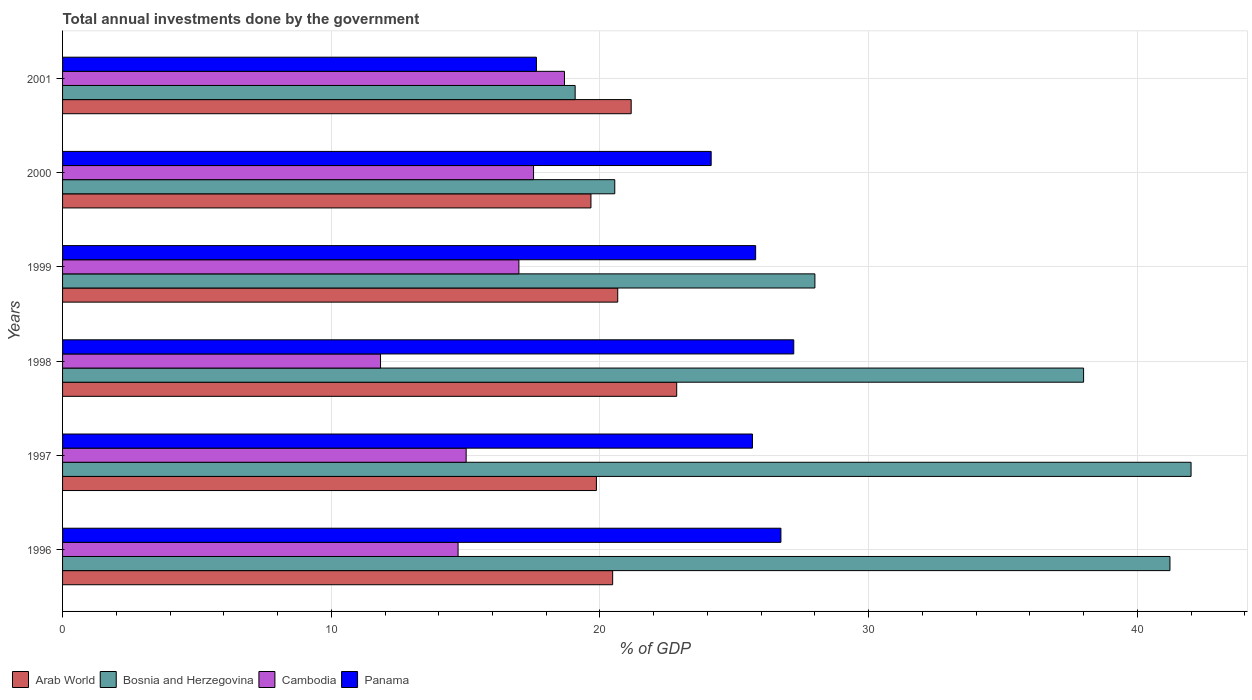How many bars are there on the 6th tick from the top?
Make the answer very short. 4. How many bars are there on the 1st tick from the bottom?
Make the answer very short. 4. What is the label of the 5th group of bars from the top?
Make the answer very short. 1997. What is the total annual investments done by the government in Cambodia in 2000?
Ensure brevity in your answer.  17.53. Across all years, what is the maximum total annual investments done by the government in Arab World?
Your response must be concise. 22.86. Across all years, what is the minimum total annual investments done by the government in Arab World?
Ensure brevity in your answer.  19.67. What is the total total annual investments done by the government in Bosnia and Herzegovina in the graph?
Provide a succinct answer. 188.84. What is the difference between the total annual investments done by the government in Panama in 1999 and that in 2000?
Your answer should be very brief. 1.66. What is the difference between the total annual investments done by the government in Panama in 2000 and the total annual investments done by the government in Cambodia in 2001?
Provide a short and direct response. 5.46. What is the average total annual investments done by the government in Arab World per year?
Make the answer very short. 20.78. In the year 1999, what is the difference between the total annual investments done by the government in Arab World and total annual investments done by the government in Cambodia?
Provide a short and direct response. 3.68. In how many years, is the total annual investments done by the government in Arab World greater than 2 %?
Offer a very short reply. 6. What is the ratio of the total annual investments done by the government in Panama in 1996 to that in 1997?
Provide a succinct answer. 1.04. Is the difference between the total annual investments done by the government in Arab World in 1996 and 1999 greater than the difference between the total annual investments done by the government in Cambodia in 1996 and 1999?
Your answer should be very brief. Yes. What is the difference between the highest and the second highest total annual investments done by the government in Bosnia and Herzegovina?
Give a very brief answer. 0.79. What is the difference between the highest and the lowest total annual investments done by the government in Arab World?
Provide a short and direct response. 3.19. In how many years, is the total annual investments done by the government in Bosnia and Herzegovina greater than the average total annual investments done by the government in Bosnia and Herzegovina taken over all years?
Provide a short and direct response. 3. Is it the case that in every year, the sum of the total annual investments done by the government in Bosnia and Herzegovina and total annual investments done by the government in Panama is greater than the sum of total annual investments done by the government in Arab World and total annual investments done by the government in Cambodia?
Your answer should be very brief. Yes. What does the 4th bar from the top in 1996 represents?
Your response must be concise. Arab World. What does the 4th bar from the bottom in 1999 represents?
Provide a succinct answer. Panama. How many bars are there?
Ensure brevity in your answer.  24. How many years are there in the graph?
Make the answer very short. 6. What is the difference between two consecutive major ticks on the X-axis?
Your answer should be compact. 10. Does the graph contain any zero values?
Offer a terse response. No. How many legend labels are there?
Make the answer very short. 4. What is the title of the graph?
Ensure brevity in your answer.  Total annual investments done by the government. Does "Turks and Caicos Islands" appear as one of the legend labels in the graph?
Offer a terse response. No. What is the label or title of the X-axis?
Offer a very short reply. % of GDP. What is the label or title of the Y-axis?
Your answer should be compact. Years. What is the % of GDP of Arab World in 1996?
Give a very brief answer. 20.47. What is the % of GDP of Bosnia and Herzegovina in 1996?
Make the answer very short. 41.21. What is the % of GDP in Cambodia in 1996?
Your answer should be compact. 14.72. What is the % of GDP in Panama in 1996?
Ensure brevity in your answer.  26.74. What is the % of GDP in Arab World in 1997?
Offer a very short reply. 19.87. What is the % of GDP in Bosnia and Herzegovina in 1997?
Give a very brief answer. 42. What is the % of GDP in Cambodia in 1997?
Keep it short and to the point. 15.02. What is the % of GDP in Panama in 1997?
Your answer should be very brief. 25.68. What is the % of GDP of Arab World in 1998?
Provide a succinct answer. 22.86. What is the % of GDP of Bosnia and Herzegovina in 1998?
Your response must be concise. 38. What is the % of GDP in Cambodia in 1998?
Make the answer very short. 11.83. What is the % of GDP in Panama in 1998?
Give a very brief answer. 27.21. What is the % of GDP of Arab World in 1999?
Keep it short and to the point. 20.66. What is the % of GDP of Bosnia and Herzegovina in 1999?
Ensure brevity in your answer.  28. What is the % of GDP of Cambodia in 1999?
Offer a terse response. 16.98. What is the % of GDP of Panama in 1999?
Provide a succinct answer. 25.79. What is the % of GDP of Arab World in 2000?
Ensure brevity in your answer.  19.67. What is the % of GDP in Bosnia and Herzegovina in 2000?
Give a very brief answer. 20.55. What is the % of GDP in Cambodia in 2000?
Keep it short and to the point. 17.53. What is the % of GDP in Panama in 2000?
Give a very brief answer. 24.14. What is the % of GDP of Arab World in 2001?
Provide a succinct answer. 21.16. What is the % of GDP in Bosnia and Herzegovina in 2001?
Offer a very short reply. 19.08. What is the % of GDP in Cambodia in 2001?
Give a very brief answer. 18.68. What is the % of GDP of Panama in 2001?
Keep it short and to the point. 17.64. Across all years, what is the maximum % of GDP in Arab World?
Give a very brief answer. 22.86. Across all years, what is the maximum % of GDP in Bosnia and Herzegovina?
Provide a succinct answer. 42. Across all years, what is the maximum % of GDP of Cambodia?
Your response must be concise. 18.68. Across all years, what is the maximum % of GDP in Panama?
Provide a succinct answer. 27.21. Across all years, what is the minimum % of GDP of Arab World?
Offer a terse response. 19.67. Across all years, what is the minimum % of GDP in Bosnia and Herzegovina?
Provide a short and direct response. 19.08. Across all years, what is the minimum % of GDP of Cambodia?
Ensure brevity in your answer.  11.83. Across all years, what is the minimum % of GDP in Panama?
Make the answer very short. 17.64. What is the total % of GDP in Arab World in the graph?
Provide a short and direct response. 124.69. What is the total % of GDP of Bosnia and Herzegovina in the graph?
Provide a short and direct response. 188.84. What is the total % of GDP in Cambodia in the graph?
Give a very brief answer. 94.77. What is the total % of GDP in Panama in the graph?
Your answer should be very brief. 147.2. What is the difference between the % of GDP of Arab World in 1996 and that in 1997?
Make the answer very short. 0.6. What is the difference between the % of GDP of Bosnia and Herzegovina in 1996 and that in 1997?
Provide a succinct answer. -0.79. What is the difference between the % of GDP of Cambodia in 1996 and that in 1997?
Your response must be concise. -0.3. What is the difference between the % of GDP in Panama in 1996 and that in 1997?
Offer a terse response. 1.06. What is the difference between the % of GDP in Arab World in 1996 and that in 1998?
Your response must be concise. -2.38. What is the difference between the % of GDP of Bosnia and Herzegovina in 1996 and that in 1998?
Provide a succinct answer. 3.21. What is the difference between the % of GDP in Cambodia in 1996 and that in 1998?
Offer a terse response. 2.89. What is the difference between the % of GDP of Panama in 1996 and that in 1998?
Offer a very short reply. -0.48. What is the difference between the % of GDP of Arab World in 1996 and that in 1999?
Your answer should be compact. -0.19. What is the difference between the % of GDP of Bosnia and Herzegovina in 1996 and that in 1999?
Your response must be concise. 13.21. What is the difference between the % of GDP in Cambodia in 1996 and that in 1999?
Offer a very short reply. -2.26. What is the difference between the % of GDP of Panama in 1996 and that in 1999?
Make the answer very short. 0.94. What is the difference between the % of GDP in Arab World in 1996 and that in 2000?
Provide a short and direct response. 0.81. What is the difference between the % of GDP of Bosnia and Herzegovina in 1996 and that in 2000?
Keep it short and to the point. 20.66. What is the difference between the % of GDP of Cambodia in 1996 and that in 2000?
Provide a succinct answer. -2.81. What is the difference between the % of GDP of Panama in 1996 and that in 2000?
Ensure brevity in your answer.  2.6. What is the difference between the % of GDP of Arab World in 1996 and that in 2001?
Keep it short and to the point. -0.69. What is the difference between the % of GDP in Bosnia and Herzegovina in 1996 and that in 2001?
Keep it short and to the point. 22.14. What is the difference between the % of GDP in Cambodia in 1996 and that in 2001?
Make the answer very short. -3.96. What is the difference between the % of GDP of Panama in 1996 and that in 2001?
Your answer should be compact. 9.1. What is the difference between the % of GDP in Arab World in 1997 and that in 1998?
Provide a succinct answer. -2.99. What is the difference between the % of GDP of Bosnia and Herzegovina in 1997 and that in 1998?
Ensure brevity in your answer.  4. What is the difference between the % of GDP of Cambodia in 1997 and that in 1998?
Make the answer very short. 3.19. What is the difference between the % of GDP in Panama in 1997 and that in 1998?
Your response must be concise. -1.54. What is the difference between the % of GDP of Arab World in 1997 and that in 1999?
Your response must be concise. -0.79. What is the difference between the % of GDP of Bosnia and Herzegovina in 1997 and that in 1999?
Offer a terse response. 14. What is the difference between the % of GDP in Cambodia in 1997 and that in 1999?
Ensure brevity in your answer.  -1.96. What is the difference between the % of GDP in Panama in 1997 and that in 1999?
Give a very brief answer. -0.12. What is the difference between the % of GDP of Arab World in 1997 and that in 2000?
Ensure brevity in your answer.  0.2. What is the difference between the % of GDP in Bosnia and Herzegovina in 1997 and that in 2000?
Your answer should be compact. 21.45. What is the difference between the % of GDP of Cambodia in 1997 and that in 2000?
Make the answer very short. -2.51. What is the difference between the % of GDP of Panama in 1997 and that in 2000?
Provide a short and direct response. 1.54. What is the difference between the % of GDP of Arab World in 1997 and that in 2001?
Your response must be concise. -1.29. What is the difference between the % of GDP of Bosnia and Herzegovina in 1997 and that in 2001?
Offer a very short reply. 22.92. What is the difference between the % of GDP in Cambodia in 1997 and that in 2001?
Your answer should be compact. -3.66. What is the difference between the % of GDP of Panama in 1997 and that in 2001?
Give a very brief answer. 8.04. What is the difference between the % of GDP in Arab World in 1998 and that in 1999?
Keep it short and to the point. 2.19. What is the difference between the % of GDP in Bosnia and Herzegovina in 1998 and that in 1999?
Ensure brevity in your answer.  10. What is the difference between the % of GDP in Cambodia in 1998 and that in 1999?
Offer a terse response. -5.15. What is the difference between the % of GDP of Panama in 1998 and that in 1999?
Make the answer very short. 1.42. What is the difference between the % of GDP of Arab World in 1998 and that in 2000?
Provide a short and direct response. 3.19. What is the difference between the % of GDP in Bosnia and Herzegovina in 1998 and that in 2000?
Ensure brevity in your answer.  17.45. What is the difference between the % of GDP of Cambodia in 1998 and that in 2000?
Keep it short and to the point. -5.7. What is the difference between the % of GDP of Panama in 1998 and that in 2000?
Offer a very short reply. 3.07. What is the difference between the % of GDP of Arab World in 1998 and that in 2001?
Make the answer very short. 1.69. What is the difference between the % of GDP of Bosnia and Herzegovina in 1998 and that in 2001?
Offer a terse response. 18.92. What is the difference between the % of GDP in Cambodia in 1998 and that in 2001?
Provide a short and direct response. -6.85. What is the difference between the % of GDP of Panama in 1998 and that in 2001?
Your answer should be compact. 9.58. What is the difference between the % of GDP in Bosnia and Herzegovina in 1999 and that in 2000?
Provide a short and direct response. 7.45. What is the difference between the % of GDP in Cambodia in 1999 and that in 2000?
Offer a very short reply. -0.55. What is the difference between the % of GDP in Panama in 1999 and that in 2000?
Make the answer very short. 1.66. What is the difference between the % of GDP in Arab World in 1999 and that in 2001?
Make the answer very short. -0.5. What is the difference between the % of GDP of Bosnia and Herzegovina in 1999 and that in 2001?
Make the answer very short. 8.92. What is the difference between the % of GDP in Cambodia in 1999 and that in 2001?
Offer a very short reply. -1.7. What is the difference between the % of GDP in Panama in 1999 and that in 2001?
Provide a succinct answer. 8.16. What is the difference between the % of GDP of Arab World in 2000 and that in 2001?
Provide a short and direct response. -1.5. What is the difference between the % of GDP of Bosnia and Herzegovina in 2000 and that in 2001?
Your response must be concise. 1.47. What is the difference between the % of GDP of Cambodia in 2000 and that in 2001?
Offer a very short reply. -1.15. What is the difference between the % of GDP of Panama in 2000 and that in 2001?
Offer a terse response. 6.5. What is the difference between the % of GDP of Arab World in 1996 and the % of GDP of Bosnia and Herzegovina in 1997?
Ensure brevity in your answer.  -21.53. What is the difference between the % of GDP in Arab World in 1996 and the % of GDP in Cambodia in 1997?
Provide a succinct answer. 5.45. What is the difference between the % of GDP in Arab World in 1996 and the % of GDP in Panama in 1997?
Offer a terse response. -5.2. What is the difference between the % of GDP of Bosnia and Herzegovina in 1996 and the % of GDP of Cambodia in 1997?
Your answer should be very brief. 26.19. What is the difference between the % of GDP of Bosnia and Herzegovina in 1996 and the % of GDP of Panama in 1997?
Give a very brief answer. 15.54. What is the difference between the % of GDP in Cambodia in 1996 and the % of GDP in Panama in 1997?
Keep it short and to the point. -10.96. What is the difference between the % of GDP in Arab World in 1996 and the % of GDP in Bosnia and Herzegovina in 1998?
Make the answer very short. -17.53. What is the difference between the % of GDP in Arab World in 1996 and the % of GDP in Cambodia in 1998?
Your answer should be very brief. 8.64. What is the difference between the % of GDP of Arab World in 1996 and the % of GDP of Panama in 1998?
Give a very brief answer. -6.74. What is the difference between the % of GDP in Bosnia and Herzegovina in 1996 and the % of GDP in Cambodia in 1998?
Ensure brevity in your answer.  29.38. What is the difference between the % of GDP of Bosnia and Herzegovina in 1996 and the % of GDP of Panama in 1998?
Your answer should be compact. 14. What is the difference between the % of GDP of Cambodia in 1996 and the % of GDP of Panama in 1998?
Offer a very short reply. -12.49. What is the difference between the % of GDP of Arab World in 1996 and the % of GDP of Bosnia and Herzegovina in 1999?
Keep it short and to the point. -7.53. What is the difference between the % of GDP of Arab World in 1996 and the % of GDP of Cambodia in 1999?
Your answer should be very brief. 3.49. What is the difference between the % of GDP in Arab World in 1996 and the % of GDP in Panama in 1999?
Keep it short and to the point. -5.32. What is the difference between the % of GDP of Bosnia and Herzegovina in 1996 and the % of GDP of Cambodia in 1999?
Give a very brief answer. 24.23. What is the difference between the % of GDP of Bosnia and Herzegovina in 1996 and the % of GDP of Panama in 1999?
Keep it short and to the point. 15.42. What is the difference between the % of GDP of Cambodia in 1996 and the % of GDP of Panama in 1999?
Offer a terse response. -11.07. What is the difference between the % of GDP of Arab World in 1996 and the % of GDP of Bosnia and Herzegovina in 2000?
Provide a succinct answer. -0.08. What is the difference between the % of GDP in Arab World in 1996 and the % of GDP in Cambodia in 2000?
Provide a short and direct response. 2.94. What is the difference between the % of GDP of Arab World in 1996 and the % of GDP of Panama in 2000?
Your answer should be very brief. -3.67. What is the difference between the % of GDP of Bosnia and Herzegovina in 1996 and the % of GDP of Cambodia in 2000?
Offer a very short reply. 23.68. What is the difference between the % of GDP in Bosnia and Herzegovina in 1996 and the % of GDP in Panama in 2000?
Offer a very short reply. 17.07. What is the difference between the % of GDP in Cambodia in 1996 and the % of GDP in Panama in 2000?
Ensure brevity in your answer.  -9.42. What is the difference between the % of GDP of Arab World in 1996 and the % of GDP of Bosnia and Herzegovina in 2001?
Give a very brief answer. 1.4. What is the difference between the % of GDP in Arab World in 1996 and the % of GDP in Cambodia in 2001?
Your answer should be very brief. 1.79. What is the difference between the % of GDP of Arab World in 1996 and the % of GDP of Panama in 2001?
Give a very brief answer. 2.84. What is the difference between the % of GDP of Bosnia and Herzegovina in 1996 and the % of GDP of Cambodia in 2001?
Make the answer very short. 22.53. What is the difference between the % of GDP in Bosnia and Herzegovina in 1996 and the % of GDP in Panama in 2001?
Offer a very short reply. 23.58. What is the difference between the % of GDP of Cambodia in 1996 and the % of GDP of Panama in 2001?
Keep it short and to the point. -2.92. What is the difference between the % of GDP of Arab World in 1997 and the % of GDP of Bosnia and Herzegovina in 1998?
Your response must be concise. -18.13. What is the difference between the % of GDP in Arab World in 1997 and the % of GDP in Cambodia in 1998?
Your response must be concise. 8.03. What is the difference between the % of GDP of Arab World in 1997 and the % of GDP of Panama in 1998?
Provide a short and direct response. -7.35. What is the difference between the % of GDP in Bosnia and Herzegovina in 1997 and the % of GDP in Cambodia in 1998?
Provide a succinct answer. 30.17. What is the difference between the % of GDP in Bosnia and Herzegovina in 1997 and the % of GDP in Panama in 1998?
Make the answer very short. 14.79. What is the difference between the % of GDP of Cambodia in 1997 and the % of GDP of Panama in 1998?
Your answer should be compact. -12.19. What is the difference between the % of GDP in Arab World in 1997 and the % of GDP in Bosnia and Herzegovina in 1999?
Offer a very short reply. -8.13. What is the difference between the % of GDP of Arab World in 1997 and the % of GDP of Cambodia in 1999?
Give a very brief answer. 2.88. What is the difference between the % of GDP of Arab World in 1997 and the % of GDP of Panama in 1999?
Your answer should be very brief. -5.93. What is the difference between the % of GDP in Bosnia and Herzegovina in 1997 and the % of GDP in Cambodia in 1999?
Offer a terse response. 25.02. What is the difference between the % of GDP of Bosnia and Herzegovina in 1997 and the % of GDP of Panama in 1999?
Provide a succinct answer. 16.21. What is the difference between the % of GDP of Cambodia in 1997 and the % of GDP of Panama in 1999?
Keep it short and to the point. -10.77. What is the difference between the % of GDP in Arab World in 1997 and the % of GDP in Bosnia and Herzegovina in 2000?
Keep it short and to the point. -0.68. What is the difference between the % of GDP in Arab World in 1997 and the % of GDP in Cambodia in 2000?
Provide a succinct answer. 2.34. What is the difference between the % of GDP in Arab World in 1997 and the % of GDP in Panama in 2000?
Your response must be concise. -4.27. What is the difference between the % of GDP in Bosnia and Herzegovina in 1997 and the % of GDP in Cambodia in 2000?
Your response must be concise. 24.47. What is the difference between the % of GDP of Bosnia and Herzegovina in 1997 and the % of GDP of Panama in 2000?
Your response must be concise. 17.86. What is the difference between the % of GDP of Cambodia in 1997 and the % of GDP of Panama in 2000?
Your answer should be very brief. -9.12. What is the difference between the % of GDP in Arab World in 1997 and the % of GDP in Bosnia and Herzegovina in 2001?
Your answer should be compact. 0.79. What is the difference between the % of GDP of Arab World in 1997 and the % of GDP of Cambodia in 2001?
Keep it short and to the point. 1.19. What is the difference between the % of GDP in Arab World in 1997 and the % of GDP in Panama in 2001?
Offer a very short reply. 2.23. What is the difference between the % of GDP in Bosnia and Herzegovina in 1997 and the % of GDP in Cambodia in 2001?
Keep it short and to the point. 23.32. What is the difference between the % of GDP in Bosnia and Herzegovina in 1997 and the % of GDP in Panama in 2001?
Provide a short and direct response. 24.36. What is the difference between the % of GDP of Cambodia in 1997 and the % of GDP of Panama in 2001?
Your answer should be very brief. -2.62. What is the difference between the % of GDP of Arab World in 1998 and the % of GDP of Bosnia and Herzegovina in 1999?
Offer a very short reply. -5.14. What is the difference between the % of GDP of Arab World in 1998 and the % of GDP of Cambodia in 1999?
Your response must be concise. 5.87. What is the difference between the % of GDP of Arab World in 1998 and the % of GDP of Panama in 1999?
Your answer should be very brief. -2.94. What is the difference between the % of GDP in Bosnia and Herzegovina in 1998 and the % of GDP in Cambodia in 1999?
Give a very brief answer. 21.02. What is the difference between the % of GDP in Bosnia and Herzegovina in 1998 and the % of GDP in Panama in 1999?
Give a very brief answer. 12.21. What is the difference between the % of GDP in Cambodia in 1998 and the % of GDP in Panama in 1999?
Provide a succinct answer. -13.96. What is the difference between the % of GDP in Arab World in 1998 and the % of GDP in Bosnia and Herzegovina in 2000?
Your answer should be very brief. 2.31. What is the difference between the % of GDP of Arab World in 1998 and the % of GDP of Cambodia in 2000?
Your answer should be very brief. 5.33. What is the difference between the % of GDP of Arab World in 1998 and the % of GDP of Panama in 2000?
Your response must be concise. -1.28. What is the difference between the % of GDP in Bosnia and Herzegovina in 1998 and the % of GDP in Cambodia in 2000?
Keep it short and to the point. 20.47. What is the difference between the % of GDP in Bosnia and Herzegovina in 1998 and the % of GDP in Panama in 2000?
Provide a succinct answer. 13.86. What is the difference between the % of GDP of Cambodia in 1998 and the % of GDP of Panama in 2000?
Give a very brief answer. -12.31. What is the difference between the % of GDP of Arab World in 1998 and the % of GDP of Bosnia and Herzegovina in 2001?
Your response must be concise. 3.78. What is the difference between the % of GDP of Arab World in 1998 and the % of GDP of Cambodia in 2001?
Provide a short and direct response. 4.18. What is the difference between the % of GDP in Arab World in 1998 and the % of GDP in Panama in 2001?
Ensure brevity in your answer.  5.22. What is the difference between the % of GDP in Bosnia and Herzegovina in 1998 and the % of GDP in Cambodia in 2001?
Give a very brief answer. 19.32. What is the difference between the % of GDP in Bosnia and Herzegovina in 1998 and the % of GDP in Panama in 2001?
Provide a succinct answer. 20.36. What is the difference between the % of GDP in Cambodia in 1998 and the % of GDP in Panama in 2001?
Provide a succinct answer. -5.8. What is the difference between the % of GDP of Arab World in 1999 and the % of GDP of Bosnia and Herzegovina in 2000?
Keep it short and to the point. 0.11. What is the difference between the % of GDP of Arab World in 1999 and the % of GDP of Cambodia in 2000?
Your answer should be very brief. 3.13. What is the difference between the % of GDP of Arab World in 1999 and the % of GDP of Panama in 2000?
Your response must be concise. -3.48. What is the difference between the % of GDP in Bosnia and Herzegovina in 1999 and the % of GDP in Cambodia in 2000?
Ensure brevity in your answer.  10.47. What is the difference between the % of GDP in Bosnia and Herzegovina in 1999 and the % of GDP in Panama in 2000?
Make the answer very short. 3.86. What is the difference between the % of GDP in Cambodia in 1999 and the % of GDP in Panama in 2000?
Your answer should be compact. -7.16. What is the difference between the % of GDP in Arab World in 1999 and the % of GDP in Bosnia and Herzegovina in 2001?
Your response must be concise. 1.58. What is the difference between the % of GDP in Arab World in 1999 and the % of GDP in Cambodia in 2001?
Give a very brief answer. 1.98. What is the difference between the % of GDP of Arab World in 1999 and the % of GDP of Panama in 2001?
Keep it short and to the point. 3.02. What is the difference between the % of GDP of Bosnia and Herzegovina in 1999 and the % of GDP of Cambodia in 2001?
Provide a succinct answer. 9.32. What is the difference between the % of GDP in Bosnia and Herzegovina in 1999 and the % of GDP in Panama in 2001?
Offer a very short reply. 10.36. What is the difference between the % of GDP of Cambodia in 1999 and the % of GDP of Panama in 2001?
Your answer should be very brief. -0.65. What is the difference between the % of GDP of Arab World in 2000 and the % of GDP of Bosnia and Herzegovina in 2001?
Your answer should be compact. 0.59. What is the difference between the % of GDP in Arab World in 2000 and the % of GDP in Cambodia in 2001?
Ensure brevity in your answer.  0.99. What is the difference between the % of GDP of Arab World in 2000 and the % of GDP of Panama in 2001?
Your response must be concise. 2.03. What is the difference between the % of GDP in Bosnia and Herzegovina in 2000 and the % of GDP in Cambodia in 2001?
Ensure brevity in your answer.  1.87. What is the difference between the % of GDP in Bosnia and Herzegovina in 2000 and the % of GDP in Panama in 2001?
Provide a short and direct response. 2.91. What is the difference between the % of GDP of Cambodia in 2000 and the % of GDP of Panama in 2001?
Offer a terse response. -0.11. What is the average % of GDP of Arab World per year?
Make the answer very short. 20.78. What is the average % of GDP in Bosnia and Herzegovina per year?
Offer a terse response. 31.47. What is the average % of GDP of Cambodia per year?
Give a very brief answer. 15.79. What is the average % of GDP of Panama per year?
Keep it short and to the point. 24.53. In the year 1996, what is the difference between the % of GDP of Arab World and % of GDP of Bosnia and Herzegovina?
Keep it short and to the point. -20.74. In the year 1996, what is the difference between the % of GDP in Arab World and % of GDP in Cambodia?
Your response must be concise. 5.75. In the year 1996, what is the difference between the % of GDP in Arab World and % of GDP in Panama?
Your answer should be compact. -6.26. In the year 1996, what is the difference between the % of GDP in Bosnia and Herzegovina and % of GDP in Cambodia?
Your response must be concise. 26.49. In the year 1996, what is the difference between the % of GDP of Bosnia and Herzegovina and % of GDP of Panama?
Offer a very short reply. 14.48. In the year 1996, what is the difference between the % of GDP of Cambodia and % of GDP of Panama?
Keep it short and to the point. -12.02. In the year 1997, what is the difference between the % of GDP of Arab World and % of GDP of Bosnia and Herzegovina?
Offer a very short reply. -22.13. In the year 1997, what is the difference between the % of GDP in Arab World and % of GDP in Cambodia?
Provide a succinct answer. 4.85. In the year 1997, what is the difference between the % of GDP in Arab World and % of GDP in Panama?
Offer a terse response. -5.81. In the year 1997, what is the difference between the % of GDP in Bosnia and Herzegovina and % of GDP in Cambodia?
Provide a succinct answer. 26.98. In the year 1997, what is the difference between the % of GDP of Bosnia and Herzegovina and % of GDP of Panama?
Your answer should be very brief. 16.32. In the year 1997, what is the difference between the % of GDP in Cambodia and % of GDP in Panama?
Give a very brief answer. -10.66. In the year 1998, what is the difference between the % of GDP in Arab World and % of GDP in Bosnia and Herzegovina?
Your answer should be very brief. -15.14. In the year 1998, what is the difference between the % of GDP of Arab World and % of GDP of Cambodia?
Provide a succinct answer. 11.02. In the year 1998, what is the difference between the % of GDP of Arab World and % of GDP of Panama?
Offer a very short reply. -4.36. In the year 1998, what is the difference between the % of GDP in Bosnia and Herzegovina and % of GDP in Cambodia?
Make the answer very short. 26.17. In the year 1998, what is the difference between the % of GDP of Bosnia and Herzegovina and % of GDP of Panama?
Give a very brief answer. 10.79. In the year 1998, what is the difference between the % of GDP of Cambodia and % of GDP of Panama?
Provide a short and direct response. -15.38. In the year 1999, what is the difference between the % of GDP in Arab World and % of GDP in Bosnia and Herzegovina?
Your answer should be very brief. -7.34. In the year 1999, what is the difference between the % of GDP of Arab World and % of GDP of Cambodia?
Offer a very short reply. 3.68. In the year 1999, what is the difference between the % of GDP of Arab World and % of GDP of Panama?
Provide a succinct answer. -5.13. In the year 1999, what is the difference between the % of GDP in Bosnia and Herzegovina and % of GDP in Cambodia?
Your answer should be compact. 11.02. In the year 1999, what is the difference between the % of GDP of Bosnia and Herzegovina and % of GDP of Panama?
Keep it short and to the point. 2.21. In the year 1999, what is the difference between the % of GDP in Cambodia and % of GDP in Panama?
Your answer should be very brief. -8.81. In the year 2000, what is the difference between the % of GDP of Arab World and % of GDP of Bosnia and Herzegovina?
Keep it short and to the point. -0.89. In the year 2000, what is the difference between the % of GDP in Arab World and % of GDP in Cambodia?
Make the answer very short. 2.14. In the year 2000, what is the difference between the % of GDP in Arab World and % of GDP in Panama?
Offer a terse response. -4.47. In the year 2000, what is the difference between the % of GDP of Bosnia and Herzegovina and % of GDP of Cambodia?
Your answer should be very brief. 3.02. In the year 2000, what is the difference between the % of GDP in Bosnia and Herzegovina and % of GDP in Panama?
Your answer should be very brief. -3.59. In the year 2000, what is the difference between the % of GDP in Cambodia and % of GDP in Panama?
Offer a very short reply. -6.61. In the year 2001, what is the difference between the % of GDP of Arab World and % of GDP of Bosnia and Herzegovina?
Make the answer very short. 2.09. In the year 2001, what is the difference between the % of GDP of Arab World and % of GDP of Cambodia?
Make the answer very short. 2.48. In the year 2001, what is the difference between the % of GDP in Arab World and % of GDP in Panama?
Keep it short and to the point. 3.53. In the year 2001, what is the difference between the % of GDP of Bosnia and Herzegovina and % of GDP of Cambodia?
Provide a succinct answer. 0.4. In the year 2001, what is the difference between the % of GDP of Bosnia and Herzegovina and % of GDP of Panama?
Make the answer very short. 1.44. In the year 2001, what is the difference between the % of GDP in Cambodia and % of GDP in Panama?
Keep it short and to the point. 1.04. What is the ratio of the % of GDP of Arab World in 1996 to that in 1997?
Ensure brevity in your answer.  1.03. What is the ratio of the % of GDP in Bosnia and Herzegovina in 1996 to that in 1997?
Provide a succinct answer. 0.98. What is the ratio of the % of GDP of Panama in 1996 to that in 1997?
Your answer should be compact. 1.04. What is the ratio of the % of GDP in Arab World in 1996 to that in 1998?
Offer a terse response. 0.9. What is the ratio of the % of GDP in Bosnia and Herzegovina in 1996 to that in 1998?
Give a very brief answer. 1.08. What is the ratio of the % of GDP of Cambodia in 1996 to that in 1998?
Your response must be concise. 1.24. What is the ratio of the % of GDP in Panama in 1996 to that in 1998?
Offer a terse response. 0.98. What is the ratio of the % of GDP of Bosnia and Herzegovina in 1996 to that in 1999?
Keep it short and to the point. 1.47. What is the ratio of the % of GDP of Cambodia in 1996 to that in 1999?
Provide a short and direct response. 0.87. What is the ratio of the % of GDP of Panama in 1996 to that in 1999?
Your answer should be compact. 1.04. What is the ratio of the % of GDP in Arab World in 1996 to that in 2000?
Offer a very short reply. 1.04. What is the ratio of the % of GDP of Bosnia and Herzegovina in 1996 to that in 2000?
Your answer should be very brief. 2.01. What is the ratio of the % of GDP of Cambodia in 1996 to that in 2000?
Your answer should be very brief. 0.84. What is the ratio of the % of GDP in Panama in 1996 to that in 2000?
Your answer should be compact. 1.11. What is the ratio of the % of GDP of Arab World in 1996 to that in 2001?
Ensure brevity in your answer.  0.97. What is the ratio of the % of GDP in Bosnia and Herzegovina in 1996 to that in 2001?
Give a very brief answer. 2.16. What is the ratio of the % of GDP in Cambodia in 1996 to that in 2001?
Give a very brief answer. 0.79. What is the ratio of the % of GDP in Panama in 1996 to that in 2001?
Offer a terse response. 1.52. What is the ratio of the % of GDP in Arab World in 1997 to that in 1998?
Keep it short and to the point. 0.87. What is the ratio of the % of GDP of Bosnia and Herzegovina in 1997 to that in 1998?
Give a very brief answer. 1.11. What is the ratio of the % of GDP of Cambodia in 1997 to that in 1998?
Provide a short and direct response. 1.27. What is the ratio of the % of GDP of Panama in 1997 to that in 1998?
Keep it short and to the point. 0.94. What is the ratio of the % of GDP in Arab World in 1997 to that in 1999?
Your response must be concise. 0.96. What is the ratio of the % of GDP in Bosnia and Herzegovina in 1997 to that in 1999?
Offer a terse response. 1.5. What is the ratio of the % of GDP of Cambodia in 1997 to that in 1999?
Provide a succinct answer. 0.88. What is the ratio of the % of GDP of Panama in 1997 to that in 1999?
Keep it short and to the point. 1. What is the ratio of the % of GDP in Arab World in 1997 to that in 2000?
Provide a short and direct response. 1.01. What is the ratio of the % of GDP in Bosnia and Herzegovina in 1997 to that in 2000?
Make the answer very short. 2.04. What is the ratio of the % of GDP of Cambodia in 1997 to that in 2000?
Your answer should be compact. 0.86. What is the ratio of the % of GDP in Panama in 1997 to that in 2000?
Keep it short and to the point. 1.06. What is the ratio of the % of GDP in Arab World in 1997 to that in 2001?
Your response must be concise. 0.94. What is the ratio of the % of GDP in Bosnia and Herzegovina in 1997 to that in 2001?
Provide a short and direct response. 2.2. What is the ratio of the % of GDP in Cambodia in 1997 to that in 2001?
Your answer should be very brief. 0.8. What is the ratio of the % of GDP in Panama in 1997 to that in 2001?
Your answer should be very brief. 1.46. What is the ratio of the % of GDP in Arab World in 1998 to that in 1999?
Give a very brief answer. 1.11. What is the ratio of the % of GDP of Bosnia and Herzegovina in 1998 to that in 1999?
Your answer should be compact. 1.36. What is the ratio of the % of GDP in Cambodia in 1998 to that in 1999?
Ensure brevity in your answer.  0.7. What is the ratio of the % of GDP of Panama in 1998 to that in 1999?
Offer a terse response. 1.05. What is the ratio of the % of GDP in Arab World in 1998 to that in 2000?
Give a very brief answer. 1.16. What is the ratio of the % of GDP of Bosnia and Herzegovina in 1998 to that in 2000?
Your answer should be very brief. 1.85. What is the ratio of the % of GDP of Cambodia in 1998 to that in 2000?
Give a very brief answer. 0.68. What is the ratio of the % of GDP in Panama in 1998 to that in 2000?
Give a very brief answer. 1.13. What is the ratio of the % of GDP of Arab World in 1998 to that in 2001?
Give a very brief answer. 1.08. What is the ratio of the % of GDP of Bosnia and Herzegovina in 1998 to that in 2001?
Your answer should be compact. 1.99. What is the ratio of the % of GDP of Cambodia in 1998 to that in 2001?
Make the answer very short. 0.63. What is the ratio of the % of GDP of Panama in 1998 to that in 2001?
Your answer should be compact. 1.54. What is the ratio of the % of GDP in Arab World in 1999 to that in 2000?
Ensure brevity in your answer.  1.05. What is the ratio of the % of GDP of Bosnia and Herzegovina in 1999 to that in 2000?
Offer a terse response. 1.36. What is the ratio of the % of GDP in Cambodia in 1999 to that in 2000?
Your answer should be compact. 0.97. What is the ratio of the % of GDP of Panama in 1999 to that in 2000?
Give a very brief answer. 1.07. What is the ratio of the % of GDP of Arab World in 1999 to that in 2001?
Keep it short and to the point. 0.98. What is the ratio of the % of GDP in Bosnia and Herzegovina in 1999 to that in 2001?
Your response must be concise. 1.47. What is the ratio of the % of GDP of Cambodia in 1999 to that in 2001?
Your answer should be very brief. 0.91. What is the ratio of the % of GDP of Panama in 1999 to that in 2001?
Make the answer very short. 1.46. What is the ratio of the % of GDP in Arab World in 2000 to that in 2001?
Make the answer very short. 0.93. What is the ratio of the % of GDP in Bosnia and Herzegovina in 2000 to that in 2001?
Ensure brevity in your answer.  1.08. What is the ratio of the % of GDP in Cambodia in 2000 to that in 2001?
Keep it short and to the point. 0.94. What is the ratio of the % of GDP in Panama in 2000 to that in 2001?
Offer a very short reply. 1.37. What is the difference between the highest and the second highest % of GDP of Arab World?
Give a very brief answer. 1.69. What is the difference between the highest and the second highest % of GDP of Bosnia and Herzegovina?
Ensure brevity in your answer.  0.79. What is the difference between the highest and the second highest % of GDP in Cambodia?
Provide a succinct answer. 1.15. What is the difference between the highest and the second highest % of GDP of Panama?
Provide a succinct answer. 0.48. What is the difference between the highest and the lowest % of GDP of Arab World?
Your answer should be very brief. 3.19. What is the difference between the highest and the lowest % of GDP in Bosnia and Herzegovina?
Your answer should be compact. 22.92. What is the difference between the highest and the lowest % of GDP in Cambodia?
Keep it short and to the point. 6.85. What is the difference between the highest and the lowest % of GDP in Panama?
Offer a very short reply. 9.58. 